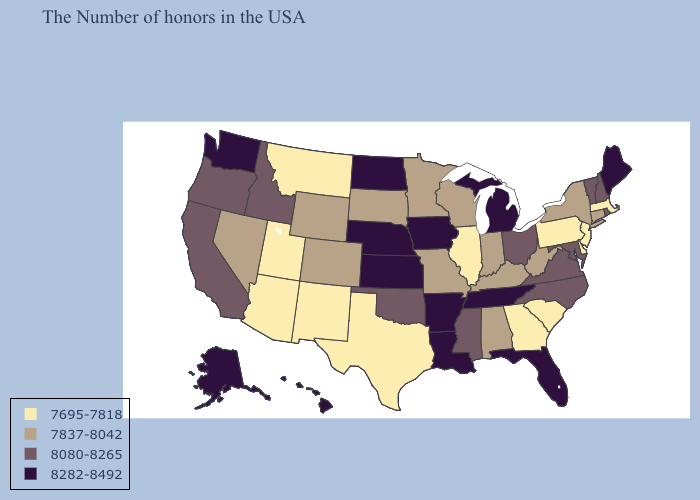What is the highest value in states that border Louisiana?
Short answer required. 8282-8492. Does Wisconsin have a lower value than New Jersey?
Concise answer only. No. What is the value of New Mexico?
Concise answer only. 7695-7818. What is the lowest value in the West?
Give a very brief answer. 7695-7818. Which states hav the highest value in the MidWest?
Be succinct. Michigan, Iowa, Kansas, Nebraska, North Dakota. What is the highest value in the Northeast ?
Short answer required. 8282-8492. Does the first symbol in the legend represent the smallest category?
Be succinct. Yes. Among the states that border West Virginia , does Maryland have the highest value?
Write a very short answer. Yes. Name the states that have a value in the range 8080-8265?
Give a very brief answer. Rhode Island, New Hampshire, Vermont, Maryland, Virginia, North Carolina, Ohio, Mississippi, Oklahoma, Idaho, California, Oregon. Does Montana have the lowest value in the West?
Write a very short answer. Yes. Name the states that have a value in the range 7837-8042?
Be succinct. Connecticut, New York, West Virginia, Kentucky, Indiana, Alabama, Wisconsin, Missouri, Minnesota, South Dakota, Wyoming, Colorado, Nevada. Among the states that border Wyoming , does Nebraska have the highest value?
Be succinct. Yes. Is the legend a continuous bar?
Answer briefly. No. Name the states that have a value in the range 7695-7818?
Short answer required. Massachusetts, New Jersey, Delaware, Pennsylvania, South Carolina, Georgia, Illinois, Texas, New Mexico, Utah, Montana, Arizona. What is the value of Florida?
Give a very brief answer. 8282-8492. 